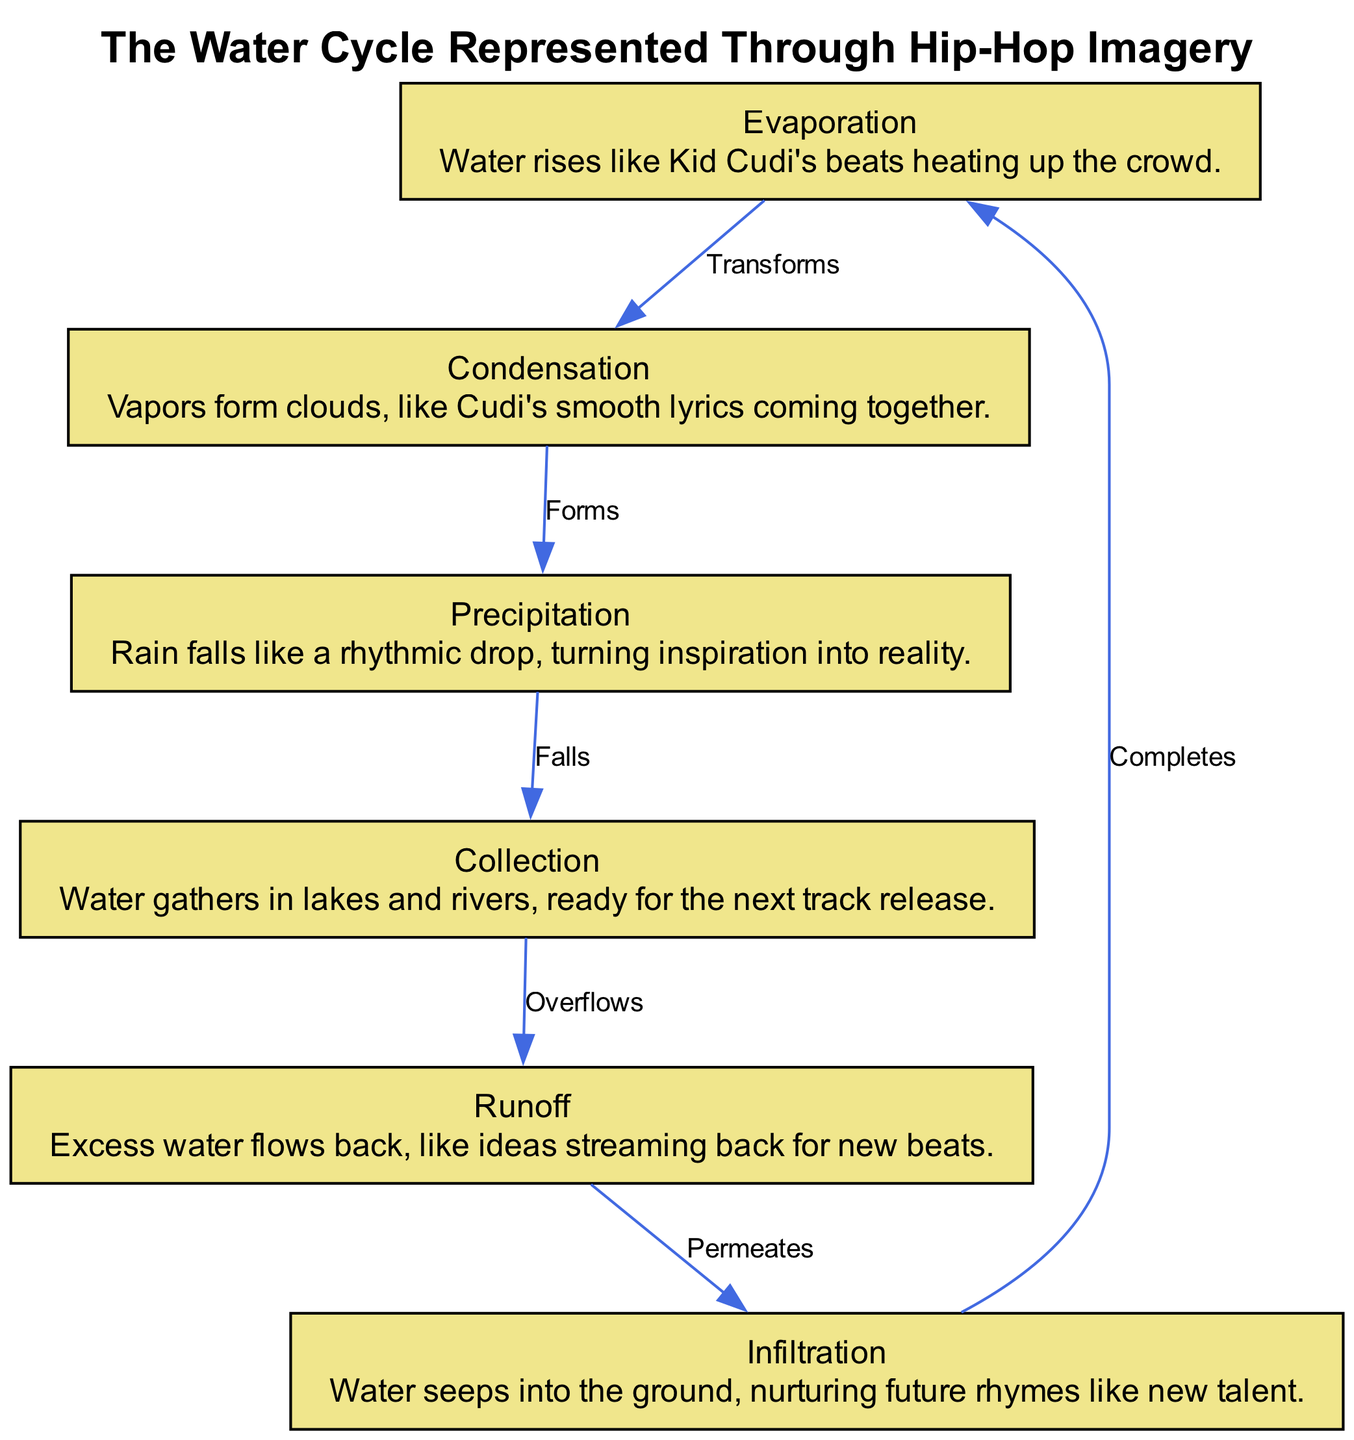What is the label of the first node? The first node in the diagram is labeled "Evaporation." This can be determined by looking at the node list provided in the data.
Answer: Evaporation How many nodes are there in the diagram? The diagram contains a total of 6 nodes, as listed in the provided data.
Answer: 6 Which node transforms into the condensation node? The evaporation node, labeled "Evaporation," transforms into the condensation node labeled "Condensation," as indicated by the edge labeled "Transforms."
Answer: Evaporation What is the final step in the water cycle according to the diagram? The final step of the water cycle is represented by the infiltration node, which completes the cycle by nurturing future rhymes. This is indicated by the edge labeled "Completes."
Answer: Infiltration What type of relationship exists between precipitation and collection? The relationship between the precipitation node and the collection node is described as "Falls," indicating that precipitation falls into collection. This is shown in the edge connecting these two nodes.
Answer: Falls Which node symbolizes the flow of excess water? The runoff node symbolizes the flow of excess water, as it is explicitly described in its definition and shown in the diagram's flow.
Answer: Runoff What does the condensation node form? The condensation node forms clouds, represented by its description which connects to the idea of vapors coming together.
Answer: Clouds Which node indicates the nurturing of new talent? The infiltration node indicates the nurturing of new talent, based on its description that compares this process to nurturing future rhymes.
Answer: Infiltration 